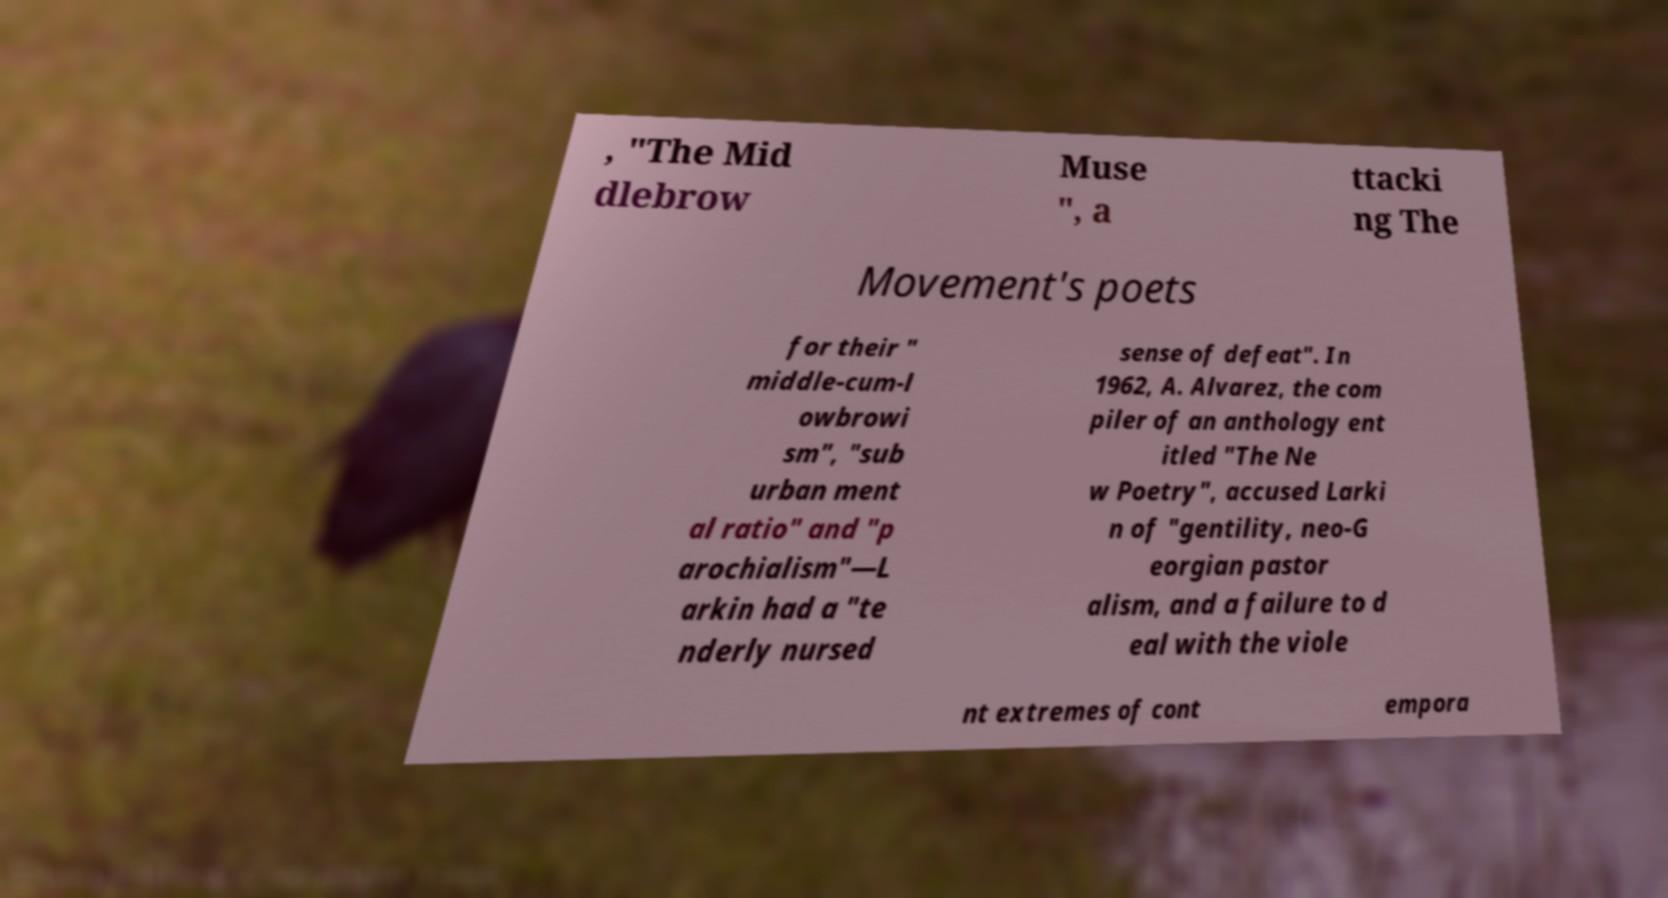Could you extract and type out the text from this image? , "The Mid dlebrow Muse ", a ttacki ng The Movement's poets for their " middle-cum-l owbrowi sm", "sub urban ment al ratio" and "p arochialism"—L arkin had a "te nderly nursed sense of defeat". In 1962, A. Alvarez, the com piler of an anthology ent itled "The Ne w Poetry", accused Larki n of "gentility, neo-G eorgian pastor alism, and a failure to d eal with the viole nt extremes of cont empora 